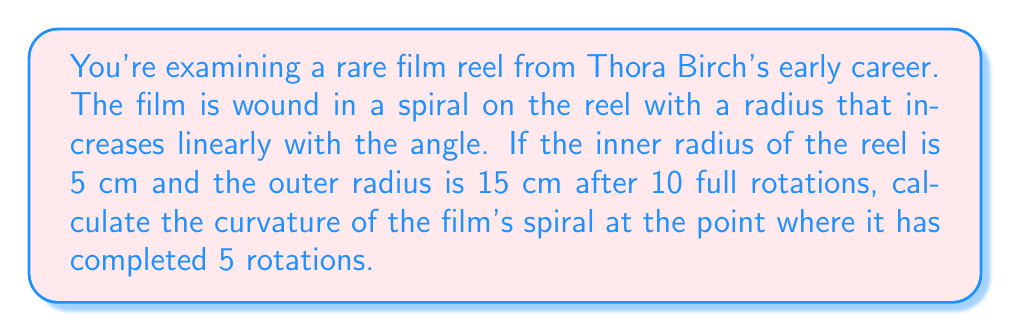Provide a solution to this math problem. Let's approach this step-by-step using differential geometry:

1) First, we need to parametrize the spiral. Let $r$ be the radius and $\theta$ be the angle. We know that $r$ increases linearly with $\theta$:

   $$r(\theta) = a\theta + b$$

   where $a$ and $b$ are constants we need to determine.

2) We can find $a$ and $b$ using the given information:
   - When $\theta = 0$, $r = 5$ cm
   - When $\theta = 20\pi$ (10 full rotations), $r = 15$ cm

   This gives us two equations:
   $$5 = b$$
   $$15 = 20\pi a + 5$$

3) Solving these, we get:
   $$b = 5$$
   $$a = \frac{1}{2\pi}$$

4) So our parametric equations for the spiral are:
   $$x(\theta) = (a\theta + b)\cos(\theta) = (\frac{\theta}{2\pi} + 5)\cos(\theta)$$
   $$y(\theta) = (a\theta + b)\sin(\theta) = (\frac{\theta}{2\pi} + 5)\sin(\theta)$$

5) To calculate curvature, we need $x'(\theta)$, $y'(\theta)$, $x''(\theta)$, and $y''(\theta)$:

   $$x'(\theta) = \frac{1}{2\pi}\cos(\theta) - (\frac{\theta}{2\pi} + 5)\sin(\theta)$$
   $$y'(\theta) = \frac{1}{2\pi}\sin(\theta) + (\frac{\theta}{2\pi} + 5)\cos(\theta)$$
   $$x''(\theta) = -\frac{1}{\pi}\sin(\theta) - (\frac{\theta}{2\pi} + 5)\cos(\theta)$$
   $$y''(\theta) = \frac{1}{\pi}\cos(\theta) - (\frac{\theta}{2\pi} + 5)\sin(\theta)$$

6) The curvature formula is:
   $$\kappa = \frac{|x'y'' - y'x''|}{(x'^2 + y'^2)^{3/2}}$$

7) At 5 rotations, $\theta = 10\pi$. Plugging this into our equations and the curvature formula:

   $$\kappa = \frac{|(\frac{1}{2\pi}\cos(10\pi) - 10\sin(10\pi))(\frac{1}{\pi}\cos(10\pi) - 10\sin(10\pi)) - (\frac{1}{2\pi}\sin(10\pi) + 10\cos(10\pi))(-\frac{1}{\pi}\sin(10\pi) - 10\cos(10\pi))|}{((\frac{1}{2\pi}\cos(10\pi) - 10\sin(10\pi))^2 + (\frac{1}{2\pi}\sin(10\pi) + 10\cos(10\pi))^2)^{3/2}}$$

8) Simplifying (noting that $\cos(10\pi) = 1$ and $\sin(10\pi) = 0$):

   $$\kappa = \frac{|\frac{1}{2\pi} \cdot \frac{1}{\pi} - 10 \cdot (-10)|}{((\frac{1}{2\pi})^2 + 10^2)^{3/2}} = \frac{100 + \frac{1}{2\pi^2}}{((\frac{1}{2\pi})^2 + 100)^{3/2}} \approx 0.0998 \text{ cm}^{-1}$$
Answer: $0.0998 \text{ cm}^{-1}$ 